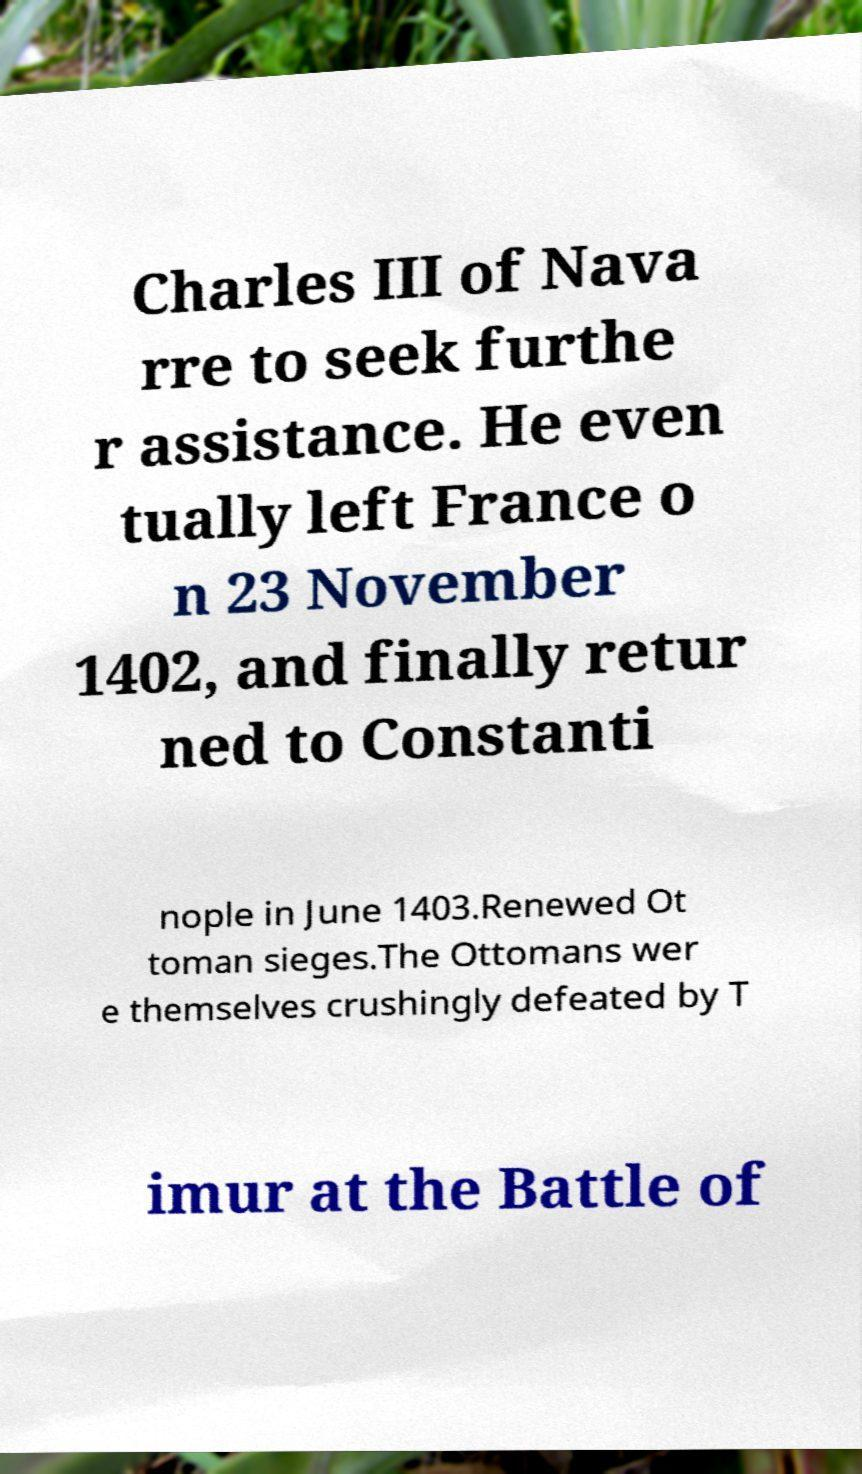I need the written content from this picture converted into text. Can you do that? Charles III of Nava rre to seek furthe r assistance. He even tually left France o n 23 November 1402, and finally retur ned to Constanti nople in June 1403.Renewed Ot toman sieges.The Ottomans wer e themselves crushingly defeated by T imur at the Battle of 